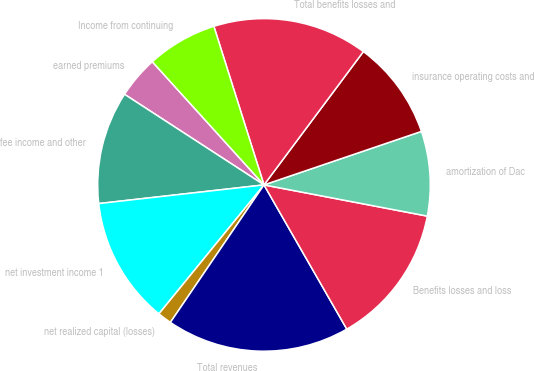Convert chart to OTSL. <chart><loc_0><loc_0><loc_500><loc_500><pie_chart><fcel>earned premiums<fcel>fee income and other<fcel>net investment income 1<fcel>net realized capital (losses)<fcel>Total revenues<fcel>Benefits losses and loss<fcel>amortization of Dac<fcel>insurance operating costs and<fcel>Total benefits losses and<fcel>Income from continuing<nl><fcel>4.11%<fcel>10.96%<fcel>12.33%<fcel>1.37%<fcel>17.81%<fcel>13.7%<fcel>8.22%<fcel>9.59%<fcel>15.07%<fcel>6.85%<nl></chart> 